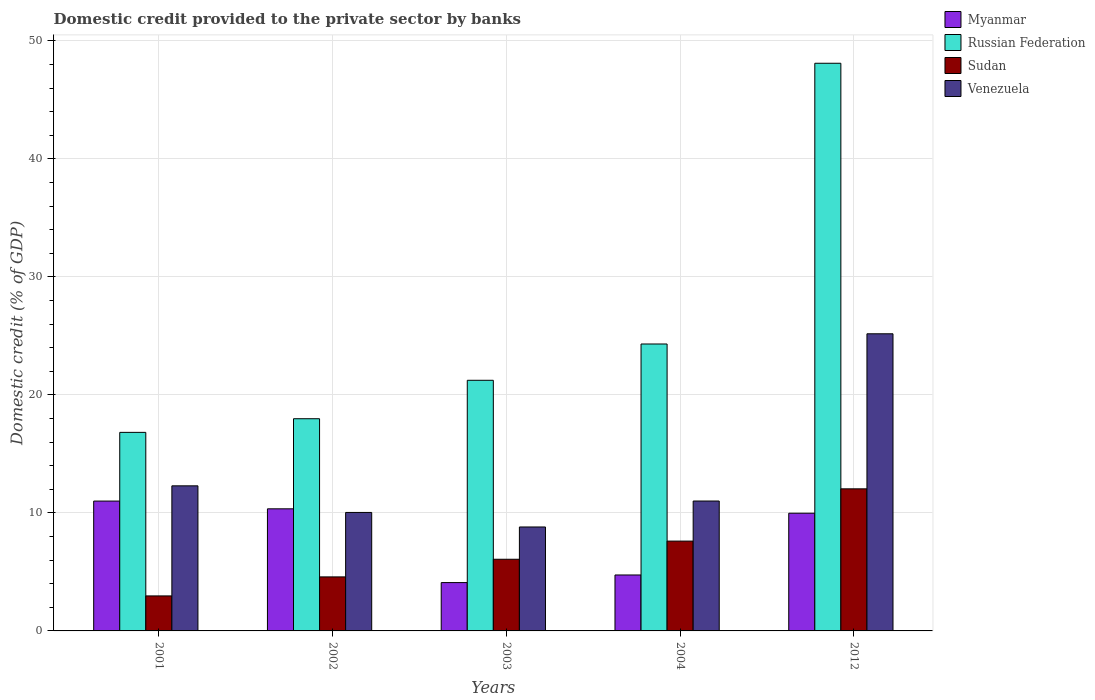How many different coloured bars are there?
Ensure brevity in your answer.  4. Are the number of bars per tick equal to the number of legend labels?
Give a very brief answer. Yes. How many bars are there on the 3rd tick from the right?
Provide a short and direct response. 4. In how many cases, is the number of bars for a given year not equal to the number of legend labels?
Make the answer very short. 0. What is the domestic credit provided to the private sector by banks in Sudan in 2001?
Your response must be concise. 2.97. Across all years, what is the maximum domestic credit provided to the private sector by banks in Venezuela?
Give a very brief answer. 25.18. Across all years, what is the minimum domestic credit provided to the private sector by banks in Russian Federation?
Your answer should be compact. 16.82. In which year was the domestic credit provided to the private sector by banks in Sudan maximum?
Offer a terse response. 2012. In which year was the domestic credit provided to the private sector by banks in Russian Federation minimum?
Offer a terse response. 2001. What is the total domestic credit provided to the private sector by banks in Sudan in the graph?
Make the answer very short. 33.26. What is the difference between the domestic credit provided to the private sector by banks in Myanmar in 2004 and that in 2012?
Your answer should be very brief. -5.23. What is the difference between the domestic credit provided to the private sector by banks in Venezuela in 2012 and the domestic credit provided to the private sector by banks in Myanmar in 2002?
Your answer should be very brief. 14.83. What is the average domestic credit provided to the private sector by banks in Myanmar per year?
Offer a terse response. 8.03. In the year 2001, what is the difference between the domestic credit provided to the private sector by banks in Russian Federation and domestic credit provided to the private sector by banks in Venezuela?
Your answer should be compact. 4.53. In how many years, is the domestic credit provided to the private sector by banks in Venezuela greater than 24 %?
Keep it short and to the point. 1. What is the ratio of the domestic credit provided to the private sector by banks in Venezuela in 2002 to that in 2003?
Offer a terse response. 1.14. Is the domestic credit provided to the private sector by banks in Russian Federation in 2003 less than that in 2004?
Make the answer very short. Yes. Is the difference between the domestic credit provided to the private sector by banks in Russian Federation in 2003 and 2004 greater than the difference between the domestic credit provided to the private sector by banks in Venezuela in 2003 and 2004?
Provide a short and direct response. No. What is the difference between the highest and the second highest domestic credit provided to the private sector by banks in Myanmar?
Offer a very short reply. 0.66. What is the difference between the highest and the lowest domestic credit provided to the private sector by banks in Russian Federation?
Give a very brief answer. 31.27. In how many years, is the domestic credit provided to the private sector by banks in Sudan greater than the average domestic credit provided to the private sector by banks in Sudan taken over all years?
Keep it short and to the point. 2. Is the sum of the domestic credit provided to the private sector by banks in Myanmar in 2003 and 2004 greater than the maximum domestic credit provided to the private sector by banks in Venezuela across all years?
Keep it short and to the point. No. Is it the case that in every year, the sum of the domestic credit provided to the private sector by banks in Sudan and domestic credit provided to the private sector by banks in Russian Federation is greater than the sum of domestic credit provided to the private sector by banks in Venezuela and domestic credit provided to the private sector by banks in Myanmar?
Make the answer very short. No. What does the 2nd bar from the left in 2001 represents?
Offer a very short reply. Russian Federation. What does the 3rd bar from the right in 2003 represents?
Give a very brief answer. Russian Federation. How many bars are there?
Provide a short and direct response. 20. How many legend labels are there?
Ensure brevity in your answer.  4. How are the legend labels stacked?
Offer a terse response. Vertical. What is the title of the graph?
Offer a terse response. Domestic credit provided to the private sector by banks. Does "Belarus" appear as one of the legend labels in the graph?
Offer a very short reply. No. What is the label or title of the X-axis?
Ensure brevity in your answer.  Years. What is the label or title of the Y-axis?
Provide a succinct answer. Domestic credit (% of GDP). What is the Domestic credit (% of GDP) of Myanmar in 2001?
Make the answer very short. 11. What is the Domestic credit (% of GDP) in Russian Federation in 2001?
Provide a succinct answer. 16.82. What is the Domestic credit (% of GDP) of Sudan in 2001?
Provide a succinct answer. 2.97. What is the Domestic credit (% of GDP) of Venezuela in 2001?
Provide a short and direct response. 12.29. What is the Domestic credit (% of GDP) in Myanmar in 2002?
Offer a very short reply. 10.34. What is the Domestic credit (% of GDP) in Russian Federation in 2002?
Make the answer very short. 17.98. What is the Domestic credit (% of GDP) in Sudan in 2002?
Your answer should be compact. 4.58. What is the Domestic credit (% of GDP) in Venezuela in 2002?
Offer a very short reply. 10.04. What is the Domestic credit (% of GDP) of Myanmar in 2003?
Make the answer very short. 4.1. What is the Domestic credit (% of GDP) in Russian Federation in 2003?
Your response must be concise. 21.24. What is the Domestic credit (% of GDP) in Sudan in 2003?
Keep it short and to the point. 6.07. What is the Domestic credit (% of GDP) of Venezuela in 2003?
Give a very brief answer. 8.81. What is the Domestic credit (% of GDP) in Myanmar in 2004?
Provide a short and direct response. 4.74. What is the Domestic credit (% of GDP) in Russian Federation in 2004?
Offer a terse response. 24.31. What is the Domestic credit (% of GDP) in Sudan in 2004?
Make the answer very short. 7.61. What is the Domestic credit (% of GDP) in Venezuela in 2004?
Keep it short and to the point. 11.01. What is the Domestic credit (% of GDP) of Myanmar in 2012?
Provide a short and direct response. 9.97. What is the Domestic credit (% of GDP) of Russian Federation in 2012?
Your answer should be compact. 48.1. What is the Domestic credit (% of GDP) of Sudan in 2012?
Provide a short and direct response. 12.04. What is the Domestic credit (% of GDP) in Venezuela in 2012?
Give a very brief answer. 25.18. Across all years, what is the maximum Domestic credit (% of GDP) of Myanmar?
Ensure brevity in your answer.  11. Across all years, what is the maximum Domestic credit (% of GDP) of Russian Federation?
Your response must be concise. 48.1. Across all years, what is the maximum Domestic credit (% of GDP) of Sudan?
Provide a short and direct response. 12.04. Across all years, what is the maximum Domestic credit (% of GDP) of Venezuela?
Make the answer very short. 25.18. Across all years, what is the minimum Domestic credit (% of GDP) in Myanmar?
Provide a succinct answer. 4.1. Across all years, what is the minimum Domestic credit (% of GDP) of Russian Federation?
Your answer should be compact. 16.82. Across all years, what is the minimum Domestic credit (% of GDP) of Sudan?
Offer a terse response. 2.97. Across all years, what is the minimum Domestic credit (% of GDP) in Venezuela?
Give a very brief answer. 8.81. What is the total Domestic credit (% of GDP) of Myanmar in the graph?
Offer a very short reply. 40.16. What is the total Domestic credit (% of GDP) of Russian Federation in the graph?
Keep it short and to the point. 128.45. What is the total Domestic credit (% of GDP) of Sudan in the graph?
Keep it short and to the point. 33.26. What is the total Domestic credit (% of GDP) in Venezuela in the graph?
Provide a short and direct response. 67.32. What is the difference between the Domestic credit (% of GDP) in Myanmar in 2001 and that in 2002?
Provide a succinct answer. 0.66. What is the difference between the Domestic credit (% of GDP) of Russian Federation in 2001 and that in 2002?
Provide a short and direct response. -1.16. What is the difference between the Domestic credit (% of GDP) of Sudan in 2001 and that in 2002?
Provide a short and direct response. -1.61. What is the difference between the Domestic credit (% of GDP) of Venezuela in 2001 and that in 2002?
Ensure brevity in your answer.  2.25. What is the difference between the Domestic credit (% of GDP) of Myanmar in 2001 and that in 2003?
Give a very brief answer. 6.91. What is the difference between the Domestic credit (% of GDP) of Russian Federation in 2001 and that in 2003?
Your answer should be very brief. -4.41. What is the difference between the Domestic credit (% of GDP) of Sudan in 2001 and that in 2003?
Give a very brief answer. -3.11. What is the difference between the Domestic credit (% of GDP) of Venezuela in 2001 and that in 2003?
Give a very brief answer. 3.49. What is the difference between the Domestic credit (% of GDP) of Myanmar in 2001 and that in 2004?
Your answer should be compact. 6.26. What is the difference between the Domestic credit (% of GDP) in Russian Federation in 2001 and that in 2004?
Your answer should be very brief. -7.49. What is the difference between the Domestic credit (% of GDP) in Sudan in 2001 and that in 2004?
Offer a terse response. -4.64. What is the difference between the Domestic credit (% of GDP) in Venezuela in 2001 and that in 2004?
Provide a short and direct response. 1.29. What is the difference between the Domestic credit (% of GDP) in Myanmar in 2001 and that in 2012?
Make the answer very short. 1.03. What is the difference between the Domestic credit (% of GDP) of Russian Federation in 2001 and that in 2012?
Offer a terse response. -31.27. What is the difference between the Domestic credit (% of GDP) in Sudan in 2001 and that in 2012?
Give a very brief answer. -9.07. What is the difference between the Domestic credit (% of GDP) of Venezuela in 2001 and that in 2012?
Give a very brief answer. -12.88. What is the difference between the Domestic credit (% of GDP) of Myanmar in 2002 and that in 2003?
Offer a terse response. 6.25. What is the difference between the Domestic credit (% of GDP) in Russian Federation in 2002 and that in 2003?
Give a very brief answer. -3.26. What is the difference between the Domestic credit (% of GDP) of Sudan in 2002 and that in 2003?
Offer a very short reply. -1.49. What is the difference between the Domestic credit (% of GDP) of Venezuela in 2002 and that in 2003?
Keep it short and to the point. 1.23. What is the difference between the Domestic credit (% of GDP) of Myanmar in 2002 and that in 2004?
Ensure brevity in your answer.  5.6. What is the difference between the Domestic credit (% of GDP) of Russian Federation in 2002 and that in 2004?
Give a very brief answer. -6.33. What is the difference between the Domestic credit (% of GDP) of Sudan in 2002 and that in 2004?
Offer a terse response. -3.03. What is the difference between the Domestic credit (% of GDP) in Venezuela in 2002 and that in 2004?
Your answer should be very brief. -0.97. What is the difference between the Domestic credit (% of GDP) in Myanmar in 2002 and that in 2012?
Provide a succinct answer. 0.37. What is the difference between the Domestic credit (% of GDP) of Russian Federation in 2002 and that in 2012?
Give a very brief answer. -30.12. What is the difference between the Domestic credit (% of GDP) of Sudan in 2002 and that in 2012?
Provide a short and direct response. -7.46. What is the difference between the Domestic credit (% of GDP) of Venezuela in 2002 and that in 2012?
Provide a succinct answer. -15.14. What is the difference between the Domestic credit (% of GDP) in Myanmar in 2003 and that in 2004?
Offer a terse response. -0.64. What is the difference between the Domestic credit (% of GDP) in Russian Federation in 2003 and that in 2004?
Your answer should be compact. -3.08. What is the difference between the Domestic credit (% of GDP) in Sudan in 2003 and that in 2004?
Provide a succinct answer. -1.54. What is the difference between the Domestic credit (% of GDP) in Venezuela in 2003 and that in 2004?
Offer a terse response. -2.2. What is the difference between the Domestic credit (% of GDP) in Myanmar in 2003 and that in 2012?
Provide a short and direct response. -5.88. What is the difference between the Domestic credit (% of GDP) of Russian Federation in 2003 and that in 2012?
Your answer should be compact. -26.86. What is the difference between the Domestic credit (% of GDP) of Sudan in 2003 and that in 2012?
Ensure brevity in your answer.  -5.97. What is the difference between the Domestic credit (% of GDP) in Venezuela in 2003 and that in 2012?
Offer a terse response. -16.37. What is the difference between the Domestic credit (% of GDP) of Myanmar in 2004 and that in 2012?
Give a very brief answer. -5.23. What is the difference between the Domestic credit (% of GDP) of Russian Federation in 2004 and that in 2012?
Your answer should be very brief. -23.79. What is the difference between the Domestic credit (% of GDP) in Sudan in 2004 and that in 2012?
Your response must be concise. -4.43. What is the difference between the Domestic credit (% of GDP) of Venezuela in 2004 and that in 2012?
Ensure brevity in your answer.  -14.17. What is the difference between the Domestic credit (% of GDP) in Myanmar in 2001 and the Domestic credit (% of GDP) in Russian Federation in 2002?
Offer a terse response. -6.98. What is the difference between the Domestic credit (% of GDP) in Myanmar in 2001 and the Domestic credit (% of GDP) in Sudan in 2002?
Provide a short and direct response. 6.42. What is the difference between the Domestic credit (% of GDP) of Myanmar in 2001 and the Domestic credit (% of GDP) of Venezuela in 2002?
Provide a short and direct response. 0.96. What is the difference between the Domestic credit (% of GDP) in Russian Federation in 2001 and the Domestic credit (% of GDP) in Sudan in 2002?
Make the answer very short. 12.25. What is the difference between the Domestic credit (% of GDP) of Russian Federation in 2001 and the Domestic credit (% of GDP) of Venezuela in 2002?
Make the answer very short. 6.78. What is the difference between the Domestic credit (% of GDP) of Sudan in 2001 and the Domestic credit (% of GDP) of Venezuela in 2002?
Make the answer very short. -7.07. What is the difference between the Domestic credit (% of GDP) of Myanmar in 2001 and the Domestic credit (% of GDP) of Russian Federation in 2003?
Make the answer very short. -10.23. What is the difference between the Domestic credit (% of GDP) of Myanmar in 2001 and the Domestic credit (% of GDP) of Sudan in 2003?
Provide a short and direct response. 4.93. What is the difference between the Domestic credit (% of GDP) of Myanmar in 2001 and the Domestic credit (% of GDP) of Venezuela in 2003?
Provide a succinct answer. 2.19. What is the difference between the Domestic credit (% of GDP) of Russian Federation in 2001 and the Domestic credit (% of GDP) of Sudan in 2003?
Offer a very short reply. 10.75. What is the difference between the Domestic credit (% of GDP) of Russian Federation in 2001 and the Domestic credit (% of GDP) of Venezuela in 2003?
Your answer should be very brief. 8.02. What is the difference between the Domestic credit (% of GDP) in Sudan in 2001 and the Domestic credit (% of GDP) in Venezuela in 2003?
Provide a short and direct response. -5.84. What is the difference between the Domestic credit (% of GDP) in Myanmar in 2001 and the Domestic credit (% of GDP) in Russian Federation in 2004?
Provide a short and direct response. -13.31. What is the difference between the Domestic credit (% of GDP) of Myanmar in 2001 and the Domestic credit (% of GDP) of Sudan in 2004?
Provide a succinct answer. 3.39. What is the difference between the Domestic credit (% of GDP) in Myanmar in 2001 and the Domestic credit (% of GDP) in Venezuela in 2004?
Provide a succinct answer. -0. What is the difference between the Domestic credit (% of GDP) in Russian Federation in 2001 and the Domestic credit (% of GDP) in Sudan in 2004?
Your answer should be compact. 9.21. What is the difference between the Domestic credit (% of GDP) in Russian Federation in 2001 and the Domestic credit (% of GDP) in Venezuela in 2004?
Offer a very short reply. 5.82. What is the difference between the Domestic credit (% of GDP) of Sudan in 2001 and the Domestic credit (% of GDP) of Venezuela in 2004?
Your response must be concise. -8.04. What is the difference between the Domestic credit (% of GDP) in Myanmar in 2001 and the Domestic credit (% of GDP) in Russian Federation in 2012?
Offer a terse response. -37.09. What is the difference between the Domestic credit (% of GDP) of Myanmar in 2001 and the Domestic credit (% of GDP) of Sudan in 2012?
Ensure brevity in your answer.  -1.04. What is the difference between the Domestic credit (% of GDP) of Myanmar in 2001 and the Domestic credit (% of GDP) of Venezuela in 2012?
Ensure brevity in your answer.  -14.17. What is the difference between the Domestic credit (% of GDP) in Russian Federation in 2001 and the Domestic credit (% of GDP) in Sudan in 2012?
Your answer should be compact. 4.78. What is the difference between the Domestic credit (% of GDP) of Russian Federation in 2001 and the Domestic credit (% of GDP) of Venezuela in 2012?
Ensure brevity in your answer.  -8.35. What is the difference between the Domestic credit (% of GDP) in Sudan in 2001 and the Domestic credit (% of GDP) in Venezuela in 2012?
Offer a very short reply. -22.21. What is the difference between the Domestic credit (% of GDP) of Myanmar in 2002 and the Domestic credit (% of GDP) of Russian Federation in 2003?
Ensure brevity in your answer.  -10.89. What is the difference between the Domestic credit (% of GDP) in Myanmar in 2002 and the Domestic credit (% of GDP) in Sudan in 2003?
Provide a short and direct response. 4.27. What is the difference between the Domestic credit (% of GDP) in Myanmar in 2002 and the Domestic credit (% of GDP) in Venezuela in 2003?
Your response must be concise. 1.54. What is the difference between the Domestic credit (% of GDP) in Russian Federation in 2002 and the Domestic credit (% of GDP) in Sudan in 2003?
Your answer should be very brief. 11.91. What is the difference between the Domestic credit (% of GDP) of Russian Federation in 2002 and the Domestic credit (% of GDP) of Venezuela in 2003?
Your answer should be very brief. 9.17. What is the difference between the Domestic credit (% of GDP) in Sudan in 2002 and the Domestic credit (% of GDP) in Venezuela in 2003?
Provide a succinct answer. -4.23. What is the difference between the Domestic credit (% of GDP) in Myanmar in 2002 and the Domestic credit (% of GDP) in Russian Federation in 2004?
Make the answer very short. -13.97. What is the difference between the Domestic credit (% of GDP) of Myanmar in 2002 and the Domestic credit (% of GDP) of Sudan in 2004?
Keep it short and to the point. 2.73. What is the difference between the Domestic credit (% of GDP) in Myanmar in 2002 and the Domestic credit (% of GDP) in Venezuela in 2004?
Offer a very short reply. -0.66. What is the difference between the Domestic credit (% of GDP) in Russian Federation in 2002 and the Domestic credit (% of GDP) in Sudan in 2004?
Provide a short and direct response. 10.37. What is the difference between the Domestic credit (% of GDP) in Russian Federation in 2002 and the Domestic credit (% of GDP) in Venezuela in 2004?
Your answer should be very brief. 6.97. What is the difference between the Domestic credit (% of GDP) of Sudan in 2002 and the Domestic credit (% of GDP) of Venezuela in 2004?
Give a very brief answer. -6.43. What is the difference between the Domestic credit (% of GDP) in Myanmar in 2002 and the Domestic credit (% of GDP) in Russian Federation in 2012?
Offer a terse response. -37.75. What is the difference between the Domestic credit (% of GDP) of Myanmar in 2002 and the Domestic credit (% of GDP) of Sudan in 2012?
Make the answer very short. -1.69. What is the difference between the Domestic credit (% of GDP) in Myanmar in 2002 and the Domestic credit (% of GDP) in Venezuela in 2012?
Give a very brief answer. -14.83. What is the difference between the Domestic credit (% of GDP) in Russian Federation in 2002 and the Domestic credit (% of GDP) in Sudan in 2012?
Give a very brief answer. 5.94. What is the difference between the Domestic credit (% of GDP) of Russian Federation in 2002 and the Domestic credit (% of GDP) of Venezuela in 2012?
Your response must be concise. -7.2. What is the difference between the Domestic credit (% of GDP) in Sudan in 2002 and the Domestic credit (% of GDP) in Venezuela in 2012?
Provide a short and direct response. -20.6. What is the difference between the Domestic credit (% of GDP) of Myanmar in 2003 and the Domestic credit (% of GDP) of Russian Federation in 2004?
Offer a terse response. -20.22. What is the difference between the Domestic credit (% of GDP) in Myanmar in 2003 and the Domestic credit (% of GDP) in Sudan in 2004?
Offer a terse response. -3.51. What is the difference between the Domestic credit (% of GDP) in Myanmar in 2003 and the Domestic credit (% of GDP) in Venezuela in 2004?
Offer a very short reply. -6.91. What is the difference between the Domestic credit (% of GDP) of Russian Federation in 2003 and the Domestic credit (% of GDP) of Sudan in 2004?
Provide a short and direct response. 13.62. What is the difference between the Domestic credit (% of GDP) in Russian Federation in 2003 and the Domestic credit (% of GDP) in Venezuela in 2004?
Make the answer very short. 10.23. What is the difference between the Domestic credit (% of GDP) in Sudan in 2003 and the Domestic credit (% of GDP) in Venezuela in 2004?
Provide a short and direct response. -4.93. What is the difference between the Domestic credit (% of GDP) in Myanmar in 2003 and the Domestic credit (% of GDP) in Russian Federation in 2012?
Your answer should be compact. -44. What is the difference between the Domestic credit (% of GDP) in Myanmar in 2003 and the Domestic credit (% of GDP) in Sudan in 2012?
Make the answer very short. -7.94. What is the difference between the Domestic credit (% of GDP) of Myanmar in 2003 and the Domestic credit (% of GDP) of Venezuela in 2012?
Your response must be concise. -21.08. What is the difference between the Domestic credit (% of GDP) of Russian Federation in 2003 and the Domestic credit (% of GDP) of Sudan in 2012?
Your answer should be very brief. 9.2. What is the difference between the Domestic credit (% of GDP) in Russian Federation in 2003 and the Domestic credit (% of GDP) in Venezuela in 2012?
Ensure brevity in your answer.  -3.94. What is the difference between the Domestic credit (% of GDP) in Sudan in 2003 and the Domestic credit (% of GDP) in Venezuela in 2012?
Give a very brief answer. -19.1. What is the difference between the Domestic credit (% of GDP) of Myanmar in 2004 and the Domestic credit (% of GDP) of Russian Federation in 2012?
Keep it short and to the point. -43.36. What is the difference between the Domestic credit (% of GDP) in Myanmar in 2004 and the Domestic credit (% of GDP) in Sudan in 2012?
Keep it short and to the point. -7.3. What is the difference between the Domestic credit (% of GDP) of Myanmar in 2004 and the Domestic credit (% of GDP) of Venezuela in 2012?
Make the answer very short. -20.44. What is the difference between the Domestic credit (% of GDP) in Russian Federation in 2004 and the Domestic credit (% of GDP) in Sudan in 2012?
Your response must be concise. 12.27. What is the difference between the Domestic credit (% of GDP) in Russian Federation in 2004 and the Domestic credit (% of GDP) in Venezuela in 2012?
Offer a terse response. -0.86. What is the difference between the Domestic credit (% of GDP) in Sudan in 2004 and the Domestic credit (% of GDP) in Venezuela in 2012?
Your response must be concise. -17.57. What is the average Domestic credit (% of GDP) in Myanmar per year?
Make the answer very short. 8.03. What is the average Domestic credit (% of GDP) of Russian Federation per year?
Ensure brevity in your answer.  25.69. What is the average Domestic credit (% of GDP) in Sudan per year?
Make the answer very short. 6.65. What is the average Domestic credit (% of GDP) in Venezuela per year?
Provide a short and direct response. 13.46. In the year 2001, what is the difference between the Domestic credit (% of GDP) in Myanmar and Domestic credit (% of GDP) in Russian Federation?
Your answer should be very brief. -5.82. In the year 2001, what is the difference between the Domestic credit (% of GDP) in Myanmar and Domestic credit (% of GDP) in Sudan?
Ensure brevity in your answer.  8.04. In the year 2001, what is the difference between the Domestic credit (% of GDP) of Myanmar and Domestic credit (% of GDP) of Venezuela?
Provide a succinct answer. -1.29. In the year 2001, what is the difference between the Domestic credit (% of GDP) of Russian Federation and Domestic credit (% of GDP) of Sudan?
Offer a very short reply. 13.86. In the year 2001, what is the difference between the Domestic credit (% of GDP) in Russian Federation and Domestic credit (% of GDP) in Venezuela?
Your answer should be compact. 4.53. In the year 2001, what is the difference between the Domestic credit (% of GDP) in Sudan and Domestic credit (% of GDP) in Venezuela?
Give a very brief answer. -9.33. In the year 2002, what is the difference between the Domestic credit (% of GDP) of Myanmar and Domestic credit (% of GDP) of Russian Federation?
Keep it short and to the point. -7.63. In the year 2002, what is the difference between the Domestic credit (% of GDP) in Myanmar and Domestic credit (% of GDP) in Sudan?
Make the answer very short. 5.77. In the year 2002, what is the difference between the Domestic credit (% of GDP) of Myanmar and Domestic credit (% of GDP) of Venezuela?
Your answer should be compact. 0.31. In the year 2002, what is the difference between the Domestic credit (% of GDP) in Russian Federation and Domestic credit (% of GDP) in Sudan?
Your answer should be compact. 13.4. In the year 2002, what is the difference between the Domestic credit (% of GDP) of Russian Federation and Domestic credit (% of GDP) of Venezuela?
Make the answer very short. 7.94. In the year 2002, what is the difference between the Domestic credit (% of GDP) of Sudan and Domestic credit (% of GDP) of Venezuela?
Give a very brief answer. -5.46. In the year 2003, what is the difference between the Domestic credit (% of GDP) of Myanmar and Domestic credit (% of GDP) of Russian Federation?
Your response must be concise. -17.14. In the year 2003, what is the difference between the Domestic credit (% of GDP) in Myanmar and Domestic credit (% of GDP) in Sudan?
Offer a very short reply. -1.98. In the year 2003, what is the difference between the Domestic credit (% of GDP) of Myanmar and Domestic credit (% of GDP) of Venezuela?
Offer a very short reply. -4.71. In the year 2003, what is the difference between the Domestic credit (% of GDP) of Russian Federation and Domestic credit (% of GDP) of Sudan?
Give a very brief answer. 15.16. In the year 2003, what is the difference between the Domestic credit (% of GDP) in Russian Federation and Domestic credit (% of GDP) in Venezuela?
Provide a succinct answer. 12.43. In the year 2003, what is the difference between the Domestic credit (% of GDP) in Sudan and Domestic credit (% of GDP) in Venezuela?
Keep it short and to the point. -2.74. In the year 2004, what is the difference between the Domestic credit (% of GDP) in Myanmar and Domestic credit (% of GDP) in Russian Federation?
Your answer should be compact. -19.57. In the year 2004, what is the difference between the Domestic credit (% of GDP) of Myanmar and Domestic credit (% of GDP) of Sudan?
Make the answer very short. -2.87. In the year 2004, what is the difference between the Domestic credit (% of GDP) in Myanmar and Domestic credit (% of GDP) in Venezuela?
Provide a short and direct response. -6.27. In the year 2004, what is the difference between the Domestic credit (% of GDP) in Russian Federation and Domestic credit (% of GDP) in Sudan?
Keep it short and to the point. 16.7. In the year 2004, what is the difference between the Domestic credit (% of GDP) of Russian Federation and Domestic credit (% of GDP) of Venezuela?
Keep it short and to the point. 13.3. In the year 2004, what is the difference between the Domestic credit (% of GDP) in Sudan and Domestic credit (% of GDP) in Venezuela?
Provide a succinct answer. -3.4. In the year 2012, what is the difference between the Domestic credit (% of GDP) in Myanmar and Domestic credit (% of GDP) in Russian Federation?
Provide a short and direct response. -38.12. In the year 2012, what is the difference between the Domestic credit (% of GDP) of Myanmar and Domestic credit (% of GDP) of Sudan?
Keep it short and to the point. -2.07. In the year 2012, what is the difference between the Domestic credit (% of GDP) of Myanmar and Domestic credit (% of GDP) of Venezuela?
Offer a terse response. -15.2. In the year 2012, what is the difference between the Domestic credit (% of GDP) in Russian Federation and Domestic credit (% of GDP) in Sudan?
Provide a short and direct response. 36.06. In the year 2012, what is the difference between the Domestic credit (% of GDP) of Russian Federation and Domestic credit (% of GDP) of Venezuela?
Your answer should be very brief. 22.92. In the year 2012, what is the difference between the Domestic credit (% of GDP) in Sudan and Domestic credit (% of GDP) in Venezuela?
Your response must be concise. -13.14. What is the ratio of the Domestic credit (% of GDP) in Myanmar in 2001 to that in 2002?
Your response must be concise. 1.06. What is the ratio of the Domestic credit (% of GDP) of Russian Federation in 2001 to that in 2002?
Ensure brevity in your answer.  0.94. What is the ratio of the Domestic credit (% of GDP) in Sudan in 2001 to that in 2002?
Your response must be concise. 0.65. What is the ratio of the Domestic credit (% of GDP) of Venezuela in 2001 to that in 2002?
Your response must be concise. 1.22. What is the ratio of the Domestic credit (% of GDP) of Myanmar in 2001 to that in 2003?
Keep it short and to the point. 2.69. What is the ratio of the Domestic credit (% of GDP) in Russian Federation in 2001 to that in 2003?
Keep it short and to the point. 0.79. What is the ratio of the Domestic credit (% of GDP) in Sudan in 2001 to that in 2003?
Provide a short and direct response. 0.49. What is the ratio of the Domestic credit (% of GDP) of Venezuela in 2001 to that in 2003?
Provide a short and direct response. 1.4. What is the ratio of the Domestic credit (% of GDP) in Myanmar in 2001 to that in 2004?
Make the answer very short. 2.32. What is the ratio of the Domestic credit (% of GDP) in Russian Federation in 2001 to that in 2004?
Ensure brevity in your answer.  0.69. What is the ratio of the Domestic credit (% of GDP) of Sudan in 2001 to that in 2004?
Your answer should be very brief. 0.39. What is the ratio of the Domestic credit (% of GDP) of Venezuela in 2001 to that in 2004?
Your answer should be compact. 1.12. What is the ratio of the Domestic credit (% of GDP) of Myanmar in 2001 to that in 2012?
Your answer should be compact. 1.1. What is the ratio of the Domestic credit (% of GDP) of Russian Federation in 2001 to that in 2012?
Offer a terse response. 0.35. What is the ratio of the Domestic credit (% of GDP) of Sudan in 2001 to that in 2012?
Make the answer very short. 0.25. What is the ratio of the Domestic credit (% of GDP) in Venezuela in 2001 to that in 2012?
Provide a short and direct response. 0.49. What is the ratio of the Domestic credit (% of GDP) of Myanmar in 2002 to that in 2003?
Give a very brief answer. 2.53. What is the ratio of the Domestic credit (% of GDP) in Russian Federation in 2002 to that in 2003?
Offer a terse response. 0.85. What is the ratio of the Domestic credit (% of GDP) of Sudan in 2002 to that in 2003?
Your response must be concise. 0.75. What is the ratio of the Domestic credit (% of GDP) in Venezuela in 2002 to that in 2003?
Your response must be concise. 1.14. What is the ratio of the Domestic credit (% of GDP) of Myanmar in 2002 to that in 2004?
Your response must be concise. 2.18. What is the ratio of the Domestic credit (% of GDP) in Russian Federation in 2002 to that in 2004?
Give a very brief answer. 0.74. What is the ratio of the Domestic credit (% of GDP) of Sudan in 2002 to that in 2004?
Offer a terse response. 0.6. What is the ratio of the Domestic credit (% of GDP) in Venezuela in 2002 to that in 2004?
Provide a short and direct response. 0.91. What is the ratio of the Domestic credit (% of GDP) of Myanmar in 2002 to that in 2012?
Keep it short and to the point. 1.04. What is the ratio of the Domestic credit (% of GDP) of Russian Federation in 2002 to that in 2012?
Your response must be concise. 0.37. What is the ratio of the Domestic credit (% of GDP) of Sudan in 2002 to that in 2012?
Your answer should be very brief. 0.38. What is the ratio of the Domestic credit (% of GDP) of Venezuela in 2002 to that in 2012?
Offer a very short reply. 0.4. What is the ratio of the Domestic credit (% of GDP) of Myanmar in 2003 to that in 2004?
Give a very brief answer. 0.86. What is the ratio of the Domestic credit (% of GDP) in Russian Federation in 2003 to that in 2004?
Offer a very short reply. 0.87. What is the ratio of the Domestic credit (% of GDP) in Sudan in 2003 to that in 2004?
Ensure brevity in your answer.  0.8. What is the ratio of the Domestic credit (% of GDP) of Venezuela in 2003 to that in 2004?
Your answer should be very brief. 0.8. What is the ratio of the Domestic credit (% of GDP) of Myanmar in 2003 to that in 2012?
Provide a short and direct response. 0.41. What is the ratio of the Domestic credit (% of GDP) in Russian Federation in 2003 to that in 2012?
Your response must be concise. 0.44. What is the ratio of the Domestic credit (% of GDP) in Sudan in 2003 to that in 2012?
Keep it short and to the point. 0.5. What is the ratio of the Domestic credit (% of GDP) in Venezuela in 2003 to that in 2012?
Offer a very short reply. 0.35. What is the ratio of the Domestic credit (% of GDP) of Myanmar in 2004 to that in 2012?
Offer a very short reply. 0.48. What is the ratio of the Domestic credit (% of GDP) in Russian Federation in 2004 to that in 2012?
Your answer should be compact. 0.51. What is the ratio of the Domestic credit (% of GDP) of Sudan in 2004 to that in 2012?
Ensure brevity in your answer.  0.63. What is the ratio of the Domestic credit (% of GDP) in Venezuela in 2004 to that in 2012?
Your answer should be very brief. 0.44. What is the difference between the highest and the second highest Domestic credit (% of GDP) of Myanmar?
Offer a terse response. 0.66. What is the difference between the highest and the second highest Domestic credit (% of GDP) of Russian Federation?
Your answer should be very brief. 23.79. What is the difference between the highest and the second highest Domestic credit (% of GDP) of Sudan?
Provide a short and direct response. 4.43. What is the difference between the highest and the second highest Domestic credit (% of GDP) in Venezuela?
Your answer should be very brief. 12.88. What is the difference between the highest and the lowest Domestic credit (% of GDP) of Myanmar?
Keep it short and to the point. 6.91. What is the difference between the highest and the lowest Domestic credit (% of GDP) in Russian Federation?
Offer a very short reply. 31.27. What is the difference between the highest and the lowest Domestic credit (% of GDP) in Sudan?
Keep it short and to the point. 9.07. What is the difference between the highest and the lowest Domestic credit (% of GDP) in Venezuela?
Your response must be concise. 16.37. 